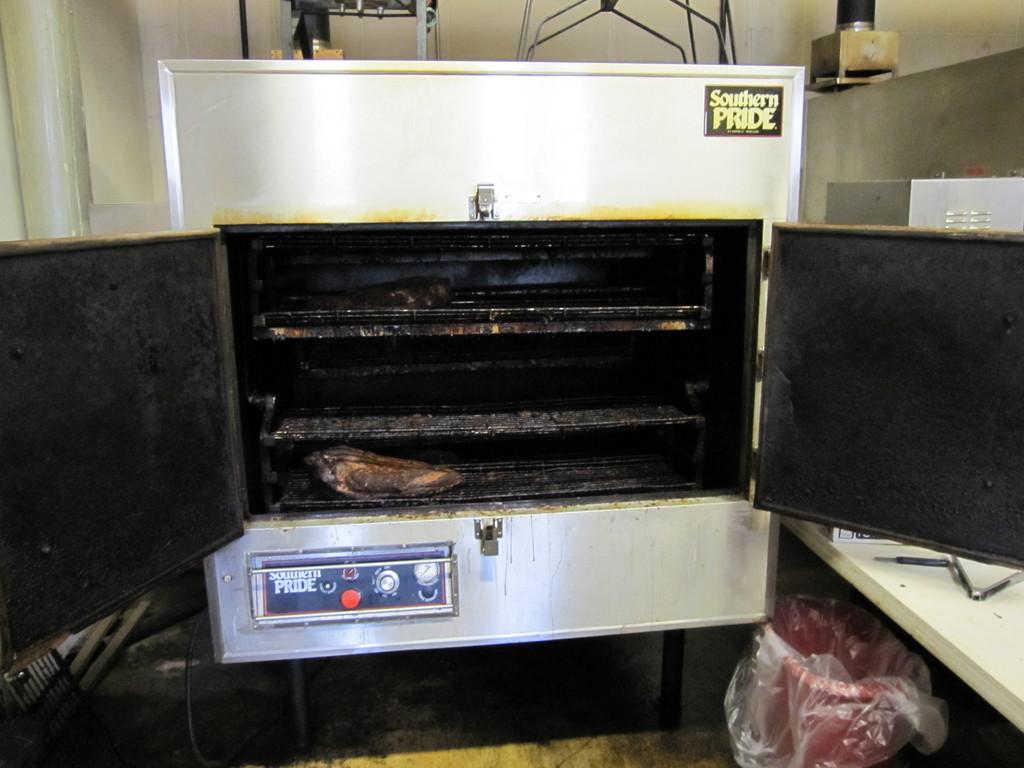What brand is this oven?
Make the answer very short. Southern pride. 